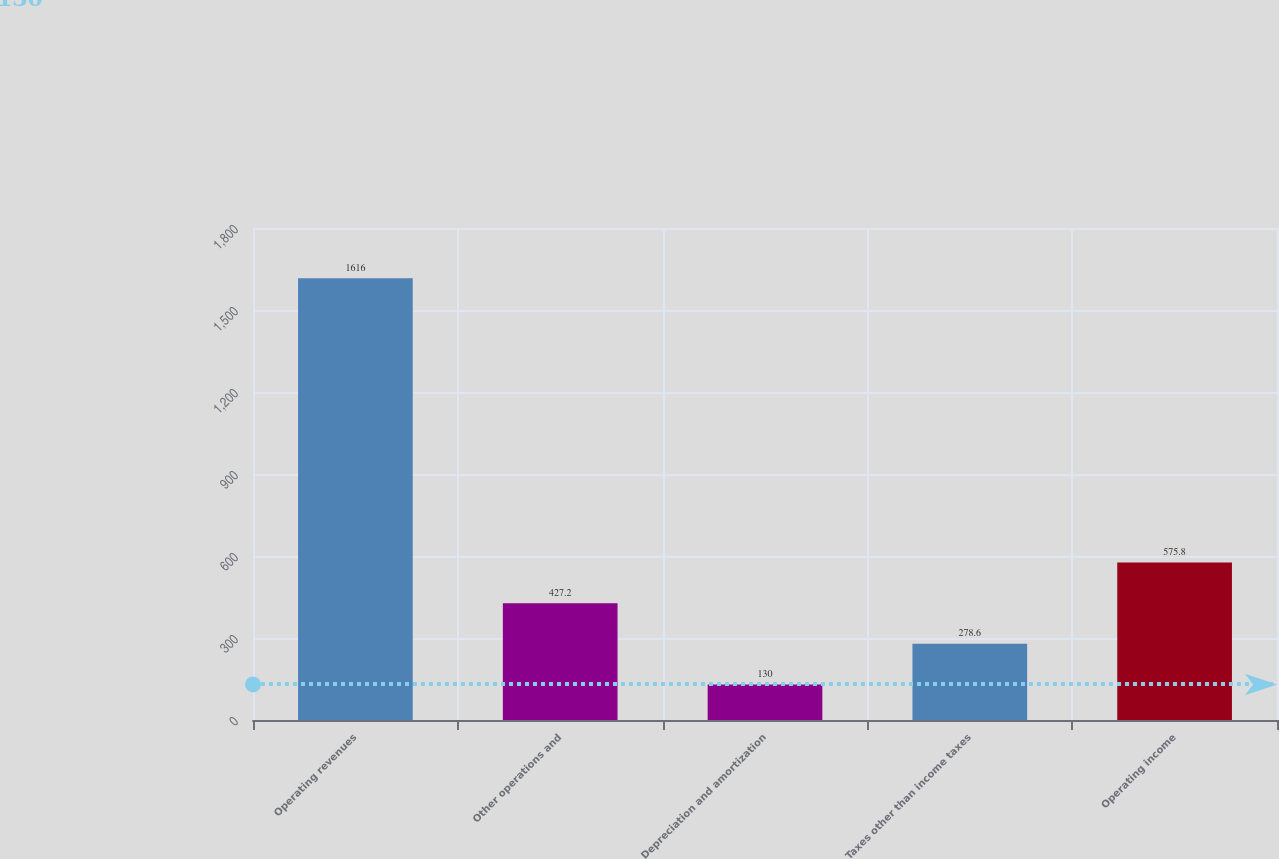<chart> <loc_0><loc_0><loc_500><loc_500><bar_chart><fcel>Operating revenues<fcel>Other operations and<fcel>Depreciation and amortization<fcel>Taxes other than income taxes<fcel>Operating income<nl><fcel>1616<fcel>427.2<fcel>130<fcel>278.6<fcel>575.8<nl></chart> 